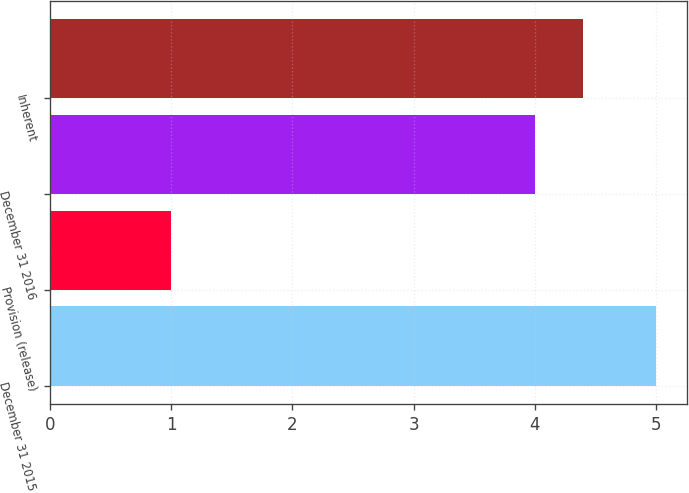<chart> <loc_0><loc_0><loc_500><loc_500><bar_chart><fcel>December 31 2015<fcel>Provision (release)<fcel>December 31 2016<fcel>Inherent<nl><fcel>5<fcel>1<fcel>4<fcel>4.4<nl></chart> 